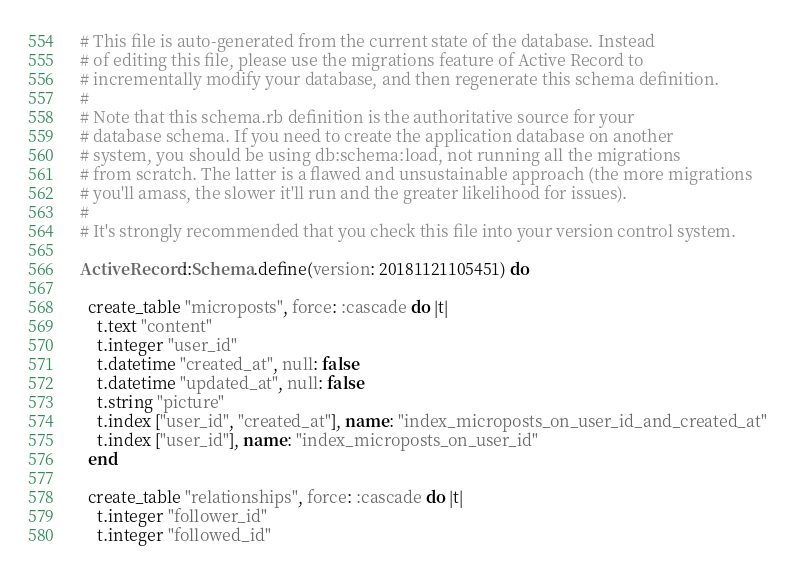Convert code to text. <code><loc_0><loc_0><loc_500><loc_500><_Ruby_># This file is auto-generated from the current state of the database. Instead
# of editing this file, please use the migrations feature of Active Record to
# incrementally modify your database, and then regenerate this schema definition.
#
# Note that this schema.rb definition is the authoritative source for your
# database schema. If you need to create the application database on another
# system, you should be using db:schema:load, not running all the migrations
# from scratch. The latter is a flawed and unsustainable approach (the more migrations
# you'll amass, the slower it'll run and the greater likelihood for issues).
#
# It's strongly recommended that you check this file into your version control system.

ActiveRecord::Schema.define(version: 20181121105451) do

  create_table "microposts", force: :cascade do |t|
    t.text "content"
    t.integer "user_id"
    t.datetime "created_at", null: false
    t.datetime "updated_at", null: false
    t.string "picture"
    t.index ["user_id", "created_at"], name: "index_microposts_on_user_id_and_created_at"
    t.index ["user_id"], name: "index_microposts_on_user_id"
  end

  create_table "relationships", force: :cascade do |t|
    t.integer "follower_id"
    t.integer "followed_id"</code> 